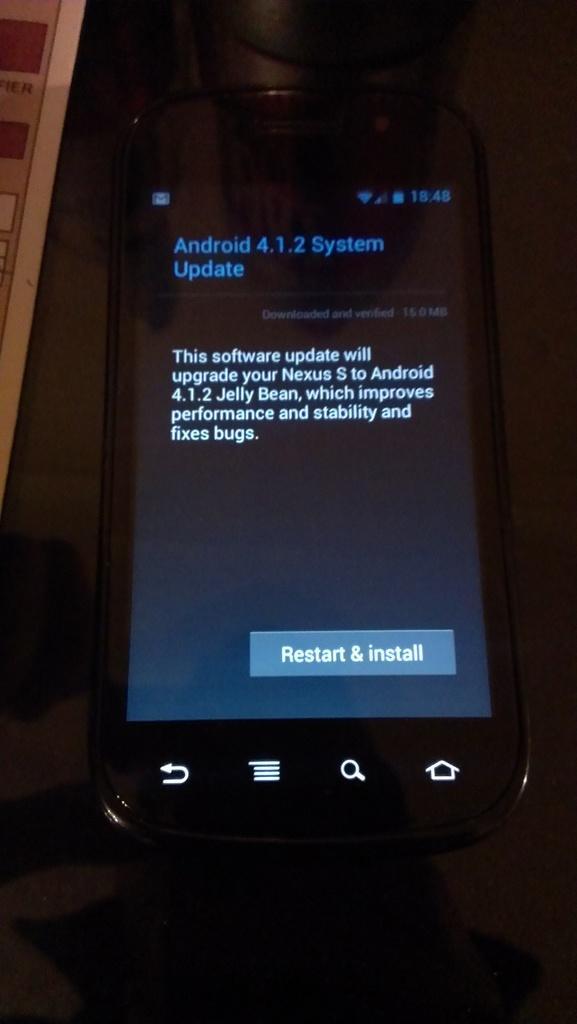Could you give a brief overview of what you see in this image? In this image we can see a cellular phone and some text displaying on the screen. 